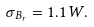Convert formula to latex. <formula><loc_0><loc_0><loc_500><loc_500>\sigma _ { B _ { r } } = 1 . 1 W .</formula> 